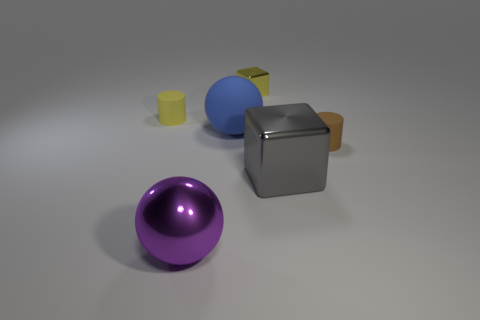Add 1 red shiny blocks. How many objects exist? 7 Subtract all cubes. How many objects are left? 4 Add 4 big purple objects. How many big purple objects are left? 5 Add 6 brown rubber cylinders. How many brown rubber cylinders exist? 7 Subtract 1 purple balls. How many objects are left? 5 Subtract all small yellow matte cubes. Subtract all cylinders. How many objects are left? 4 